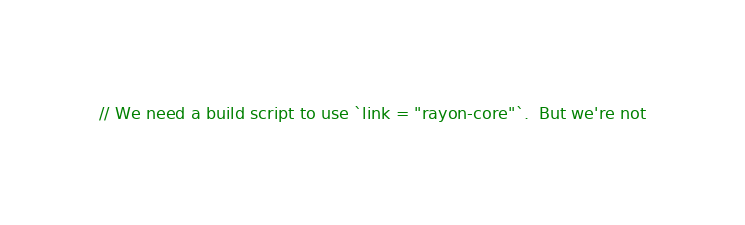Convert code to text. <code><loc_0><loc_0><loc_500><loc_500><_Rust_>// We need a build script to use `link = "rayon-core"`.  But we're not</code> 